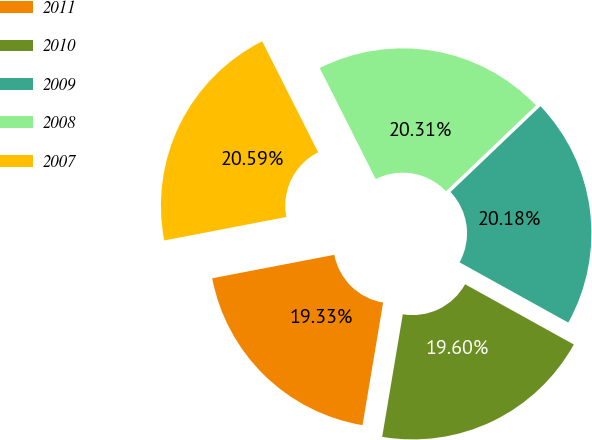Convert chart. <chart><loc_0><loc_0><loc_500><loc_500><pie_chart><fcel>2011<fcel>2010<fcel>2009<fcel>2008<fcel>2007<nl><fcel>19.33%<fcel>19.6%<fcel>20.18%<fcel>20.31%<fcel>20.59%<nl></chart> 